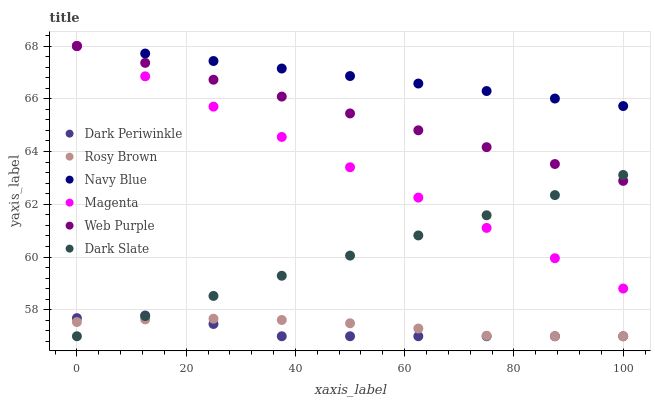Does Dark Periwinkle have the minimum area under the curve?
Answer yes or no. Yes. Does Navy Blue have the maximum area under the curve?
Answer yes or no. Yes. Does Rosy Brown have the minimum area under the curve?
Answer yes or no. No. Does Rosy Brown have the maximum area under the curve?
Answer yes or no. No. Is Dark Slate the smoothest?
Answer yes or no. Yes. Is Dark Periwinkle the roughest?
Answer yes or no. Yes. Is Rosy Brown the smoothest?
Answer yes or no. No. Is Rosy Brown the roughest?
Answer yes or no. No. Does Rosy Brown have the lowest value?
Answer yes or no. Yes. Does Web Purple have the lowest value?
Answer yes or no. No. Does Magenta have the highest value?
Answer yes or no. Yes. Does Dark Slate have the highest value?
Answer yes or no. No. Is Dark Slate less than Navy Blue?
Answer yes or no. Yes. Is Web Purple greater than Dark Periwinkle?
Answer yes or no. Yes. Does Dark Slate intersect Rosy Brown?
Answer yes or no. Yes. Is Dark Slate less than Rosy Brown?
Answer yes or no. No. Is Dark Slate greater than Rosy Brown?
Answer yes or no. No. Does Dark Slate intersect Navy Blue?
Answer yes or no. No. 